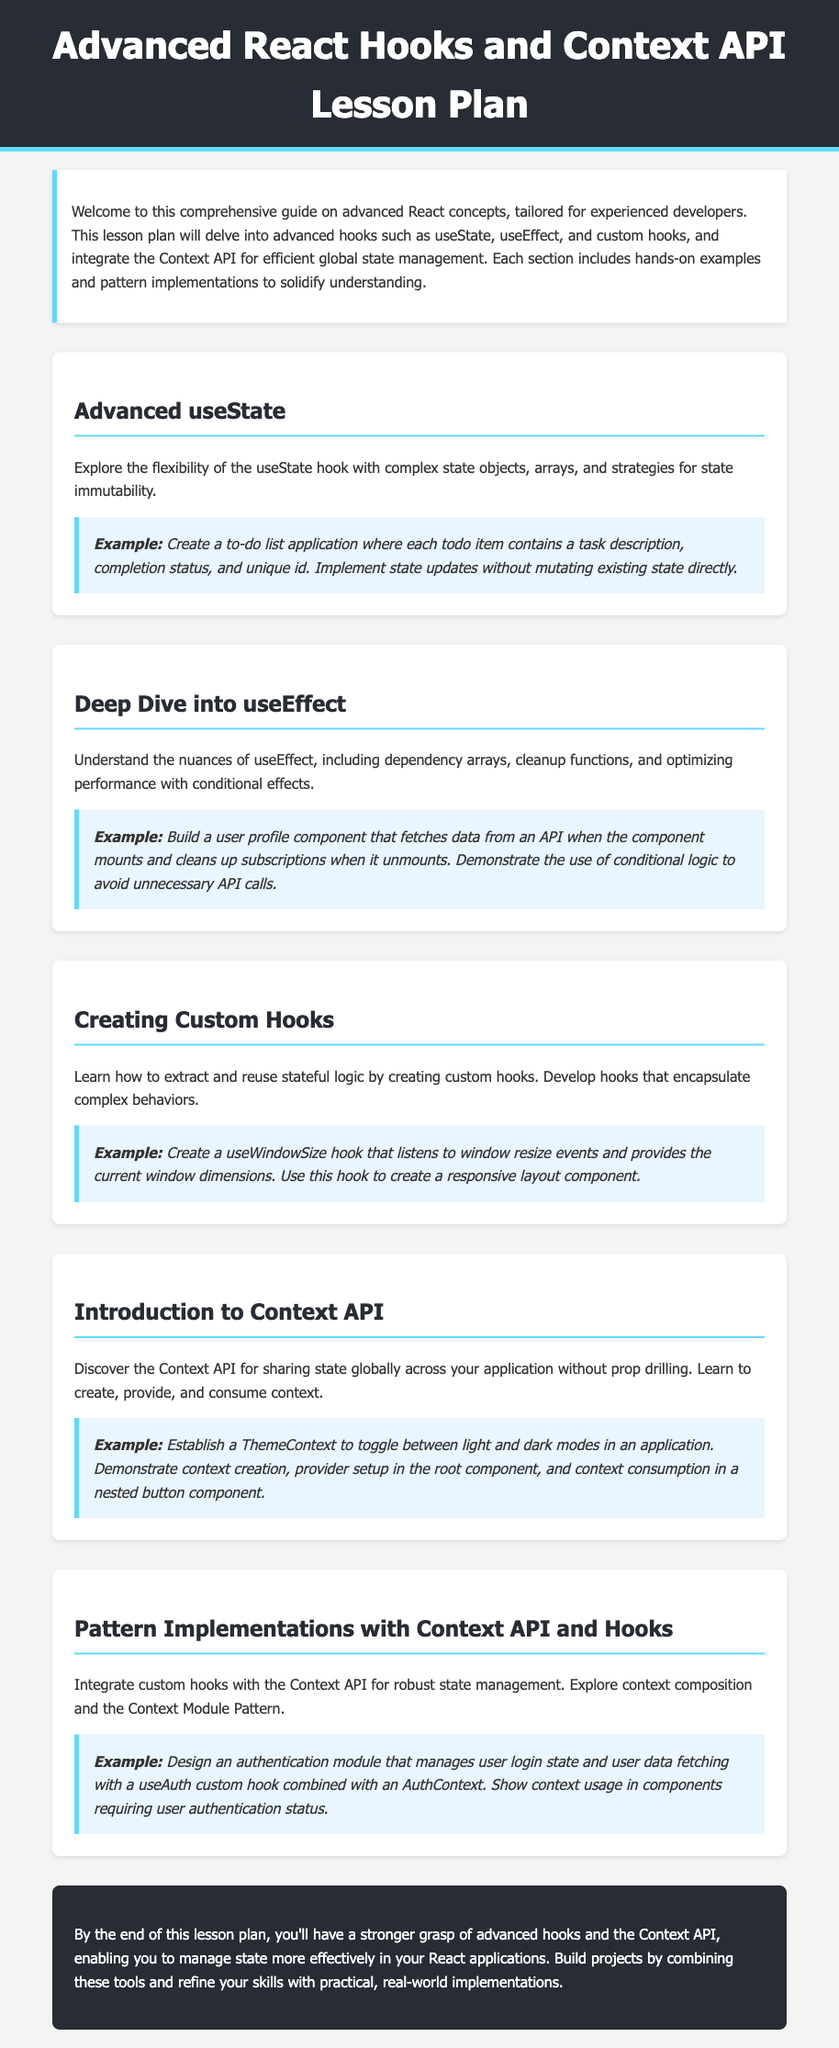What is the main focus of the lesson plan? The lesson plan is focused on advanced React concepts, specifically advanced hooks and the Context API for state management.
Answer: advanced React concepts How many sections are there in the document? The document contains five sections, each addressing different advanced topics related to React.
Answer: five What example is given for the useState hook? The document provides a to-do list application as an example for using the useState hook.
Answer: to-do list application What is the use case of the useWindowSize hook? The useWindowSize hook is designed to listen to window resize events and provide current window dimensions.
Answer: current window dimensions What does the ThemeContext manage? The ThemeContext is used to toggle between light and dark modes in an application.
Answer: light and dark modes What does the lesson plan aim to improve? The lesson plan aims to improve the understanding and management of state in React applications.
Answer: understanding and management of state What is the purpose of the Context API? The Context API is used for sharing state globally across an application without prop drilling.
Answer: sharing state globally Which example involves user authentication? The document mentions designing an authentication module that manages user login state and user data fetching.
Answer: authentication module 